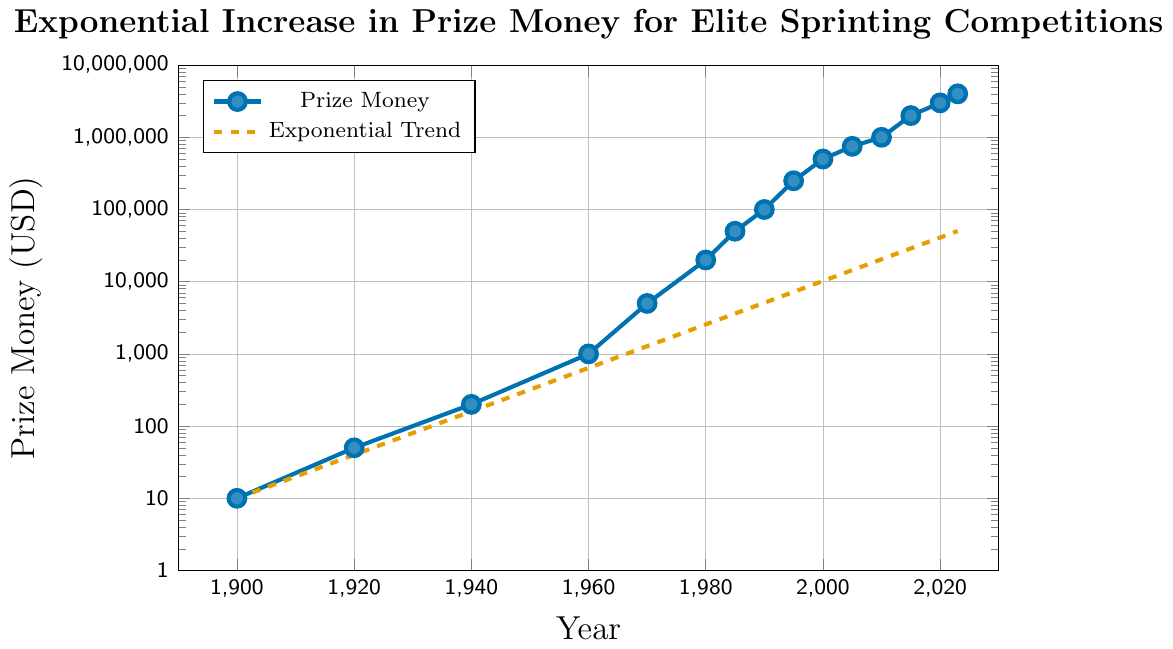What is the prize money in 1985? According to the figure, the data point for the year 1985 shows a prize money amount of 50,000 USD.
Answer: 50,000 USD How much did the prize money increase from 2000 to 2010? The prize money in 2000 was 500,000 USD and in 2010 it was 1,000,000 USD. The increase is calculated as 1,000,000 - 500,000 = 500,000 USD.
Answer: 500,000 USD Which year saw a prize money of 1000 USD? The figure shows that in the year 1960, the prize money was 1000 USD.
Answer: 1960 Between which two consecutive years was the most significant increase in prize money recorded? The most significant increase is between 1995 and 2000, where the prize money increased from 250,000 USD to 500,000 USD, marking an increase of 250,000 USD.
Answer: 1995 and 2000 How does the prize money in 1970 compare to that in 1980? In 1970, the prize money was 5000 USD. In 1980, it increased to 20000 USD. Therefore, the prize money in 1980 is four times the amount in 1970.
Answer: 4 times What is the visual difference between the prize money data points and the exponential trend line on the graph? The prize money data points are marked with blue dots and solid lines, while the exponential trend line is shown as an orange dashed line.
Answer: Blue dots and orange dashed line What is the average prize money over the entire period? To find the average, sum all prize money values and divide by the number of years: (10 + 50 + 200 + 1000 + 5000 + 20000 + 50000 + 100000 + 250000 + 500000 + 750000 + 1000000 + 2000000 + 3000000 + 4000000) / 15 = 830,867 USD
Answer: 830,867 USD Calculate the total increase in prize money from 1900 to 2023. The prize money in 1900 was 10 USD, and in 2023 it is 4000000 USD. The total increase is 4000000 - 10 = 3999990 USD.
Answer: 3,999,990 USD Identify the period with no change in prize money. The figure does not show any periods with no change, as all periods show an increase in prize money.
Answer: None 